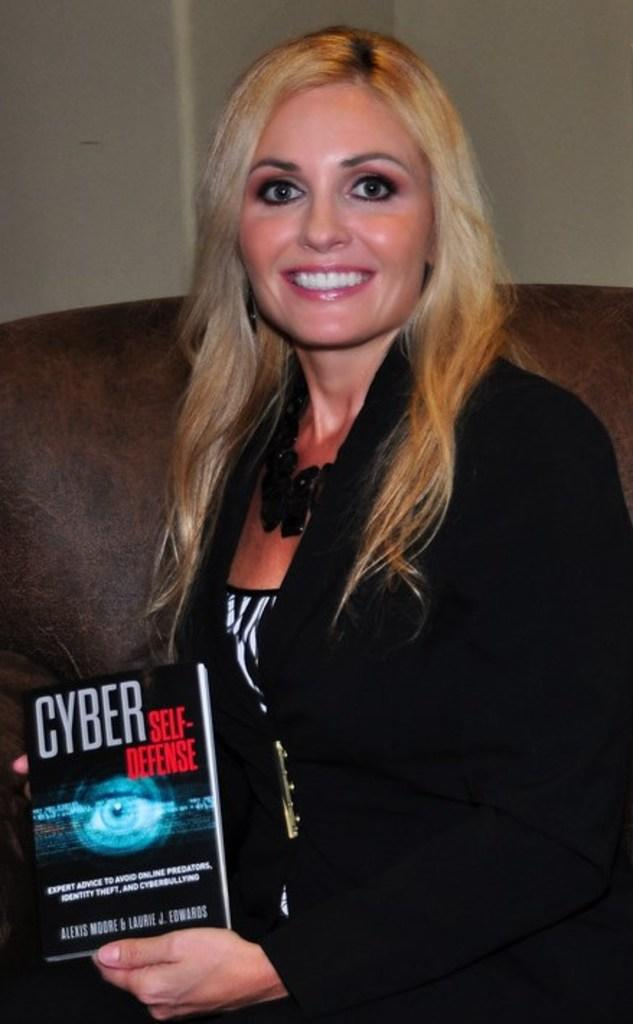Who is present in the image? There is a woman in the image. What is the woman doing in the image? The woman is smiling in the image. What object is the woman holding in the image? The woman is holding a book in the image. What type of knife is the woman using to cut the book in the image? There is no knife present in the image, and the woman is not cutting the book. 